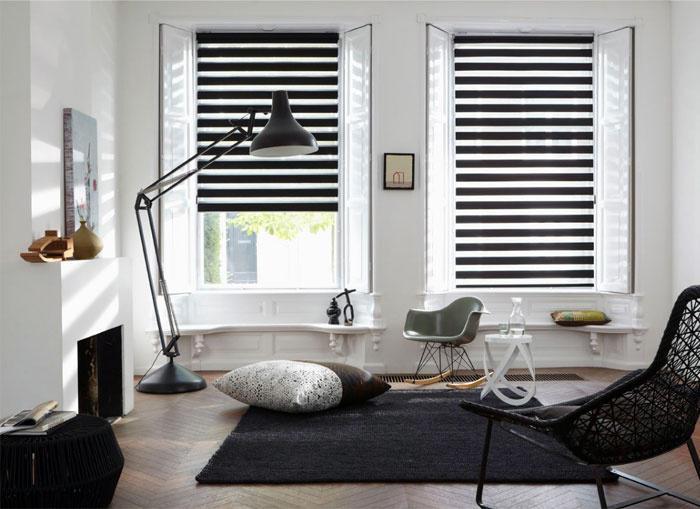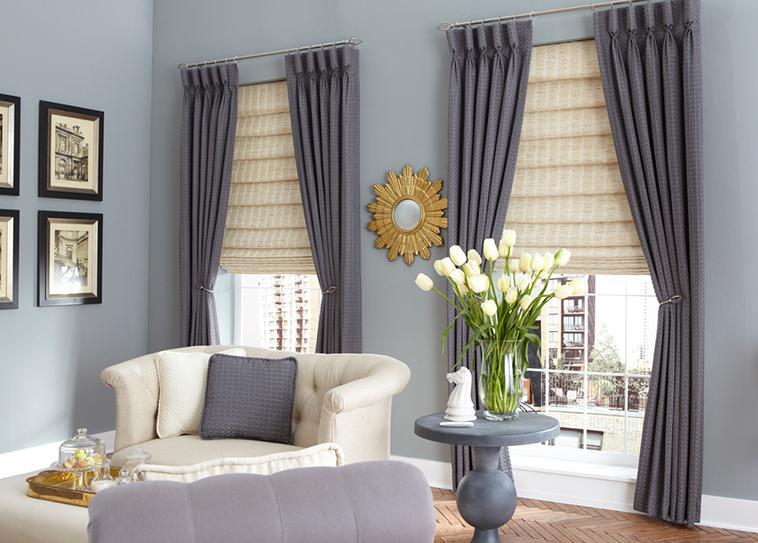The first image is the image on the left, the second image is the image on the right. Given the left and right images, does the statement "There are five blinds." hold true? Answer yes or no. No. The first image is the image on the left, the second image is the image on the right. Examine the images to the left and right. Is the description "There are exactly five shades." accurate? Answer yes or no. No. 